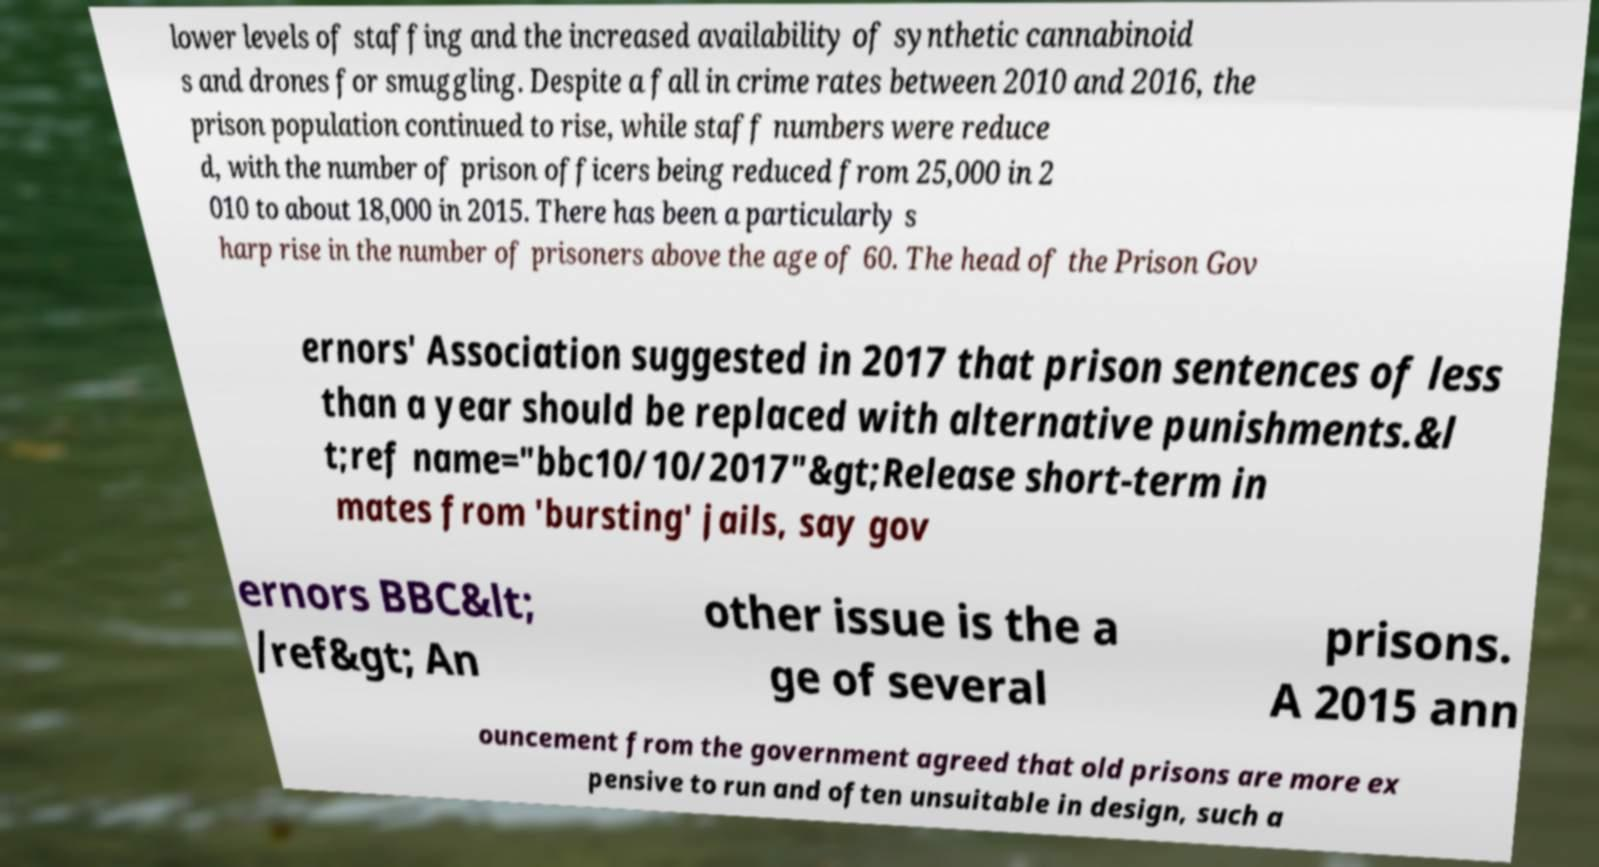I need the written content from this picture converted into text. Can you do that? lower levels of staffing and the increased availability of synthetic cannabinoid s and drones for smuggling. Despite a fall in crime rates between 2010 and 2016, the prison population continued to rise, while staff numbers were reduce d, with the number of prison officers being reduced from 25,000 in 2 010 to about 18,000 in 2015. There has been a particularly s harp rise in the number of prisoners above the age of 60. The head of the Prison Gov ernors' Association suggested in 2017 that prison sentences of less than a year should be replaced with alternative punishments.&l t;ref name="bbc10/10/2017"&gt;Release short-term in mates from 'bursting' jails, say gov ernors BBC&lt; /ref&gt; An other issue is the a ge of several prisons. A 2015 ann ouncement from the government agreed that old prisons are more ex pensive to run and often unsuitable in design, such a 